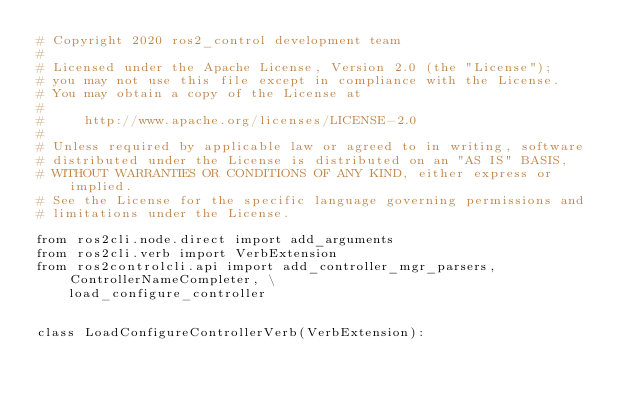<code> <loc_0><loc_0><loc_500><loc_500><_Python_># Copyright 2020 ros2_control development team
#
# Licensed under the Apache License, Version 2.0 (the "License");
# you may not use this file except in compliance with the License.
# You may obtain a copy of the License at
#
#     http://www.apache.org/licenses/LICENSE-2.0
#
# Unless required by applicable law or agreed to in writing, software
# distributed under the License is distributed on an "AS IS" BASIS,
# WITHOUT WARRANTIES OR CONDITIONS OF ANY KIND, either express or implied.
# See the License for the specific language governing permissions and
# limitations under the License.

from ros2cli.node.direct import add_arguments
from ros2cli.verb import VerbExtension
from ros2controlcli.api import add_controller_mgr_parsers, ControllerNameCompleter, \
    load_configure_controller


class LoadConfigureControllerVerb(VerbExtension):</code> 